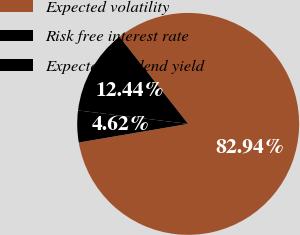Convert chart. <chart><loc_0><loc_0><loc_500><loc_500><pie_chart><fcel>Expected volatility<fcel>Risk free interest rate<fcel>Expected dividend yield<nl><fcel>82.94%<fcel>4.62%<fcel>12.44%<nl></chart> 